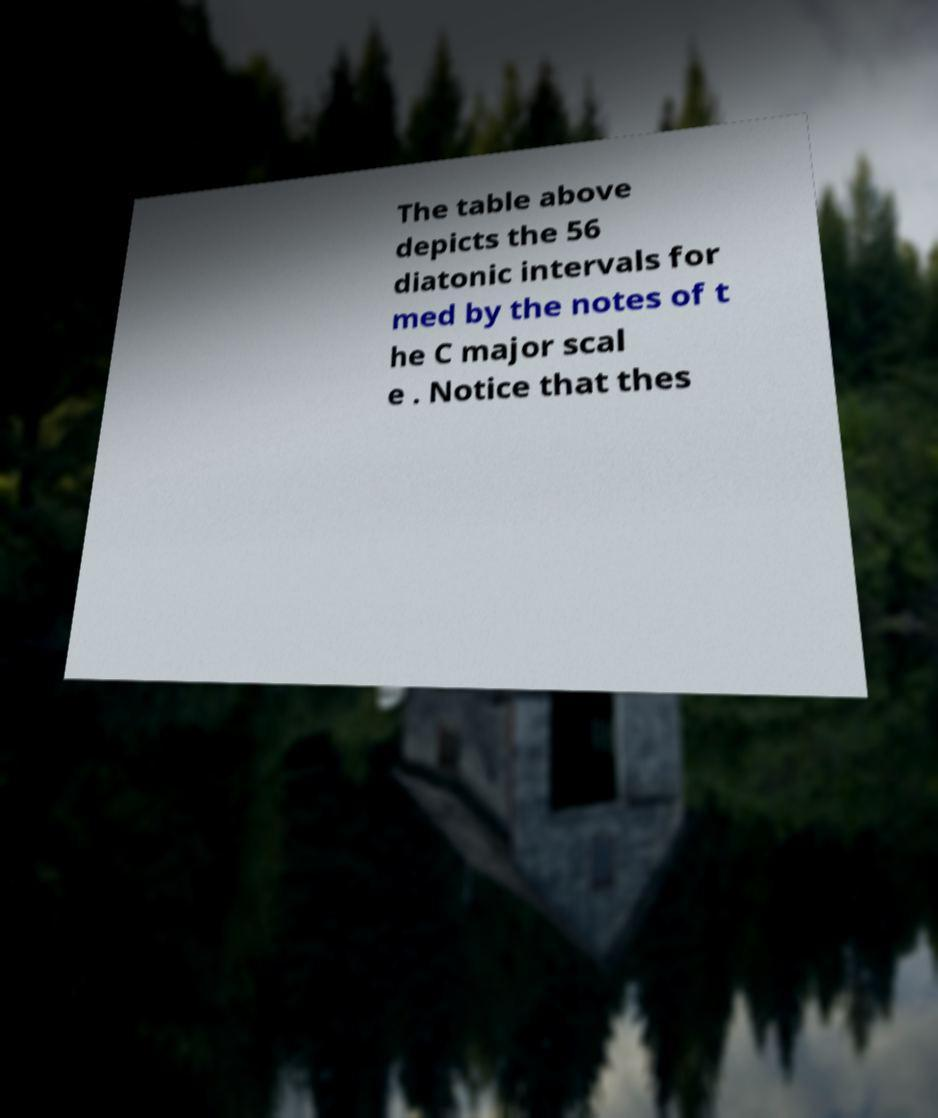Could you assist in decoding the text presented in this image and type it out clearly? The table above depicts the 56 diatonic intervals for med by the notes of t he C major scal e . Notice that thes 